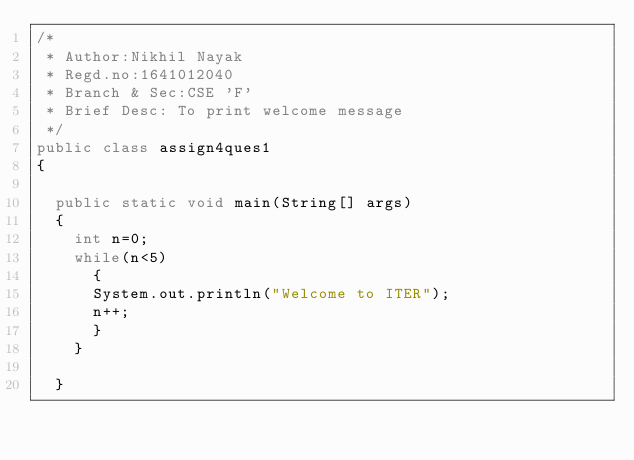<code> <loc_0><loc_0><loc_500><loc_500><_Java_>/*
 * Author:Nikhil Nayak
 * Regd.no:1641012040
 * Branch & Sec:CSE 'F'
 * Brief Desc: To print welcome message
 */
public class assign4ques1
{

	public static void main(String[] args)
	{
		int n=0;
		while(n<5)
			{
			System.out.println("Welcome to ITER");
			n++;
			}
		}

	}
</code> 